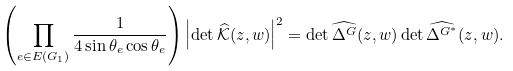<formula> <loc_0><loc_0><loc_500><loc_500>\left ( \prod _ { e \in E ( G _ { 1 } ) } \frac { 1 } { 4 \sin \theta _ { e } \cos \theta _ { e } } \right ) \left | \det \widehat { \mathcal { K } } ( z , w ) \right | ^ { 2 } = \det \widehat { \Delta ^ { G } } ( z , w ) \det \widehat { \Delta ^ { G ^ { * } } } ( z , w ) .</formula> 